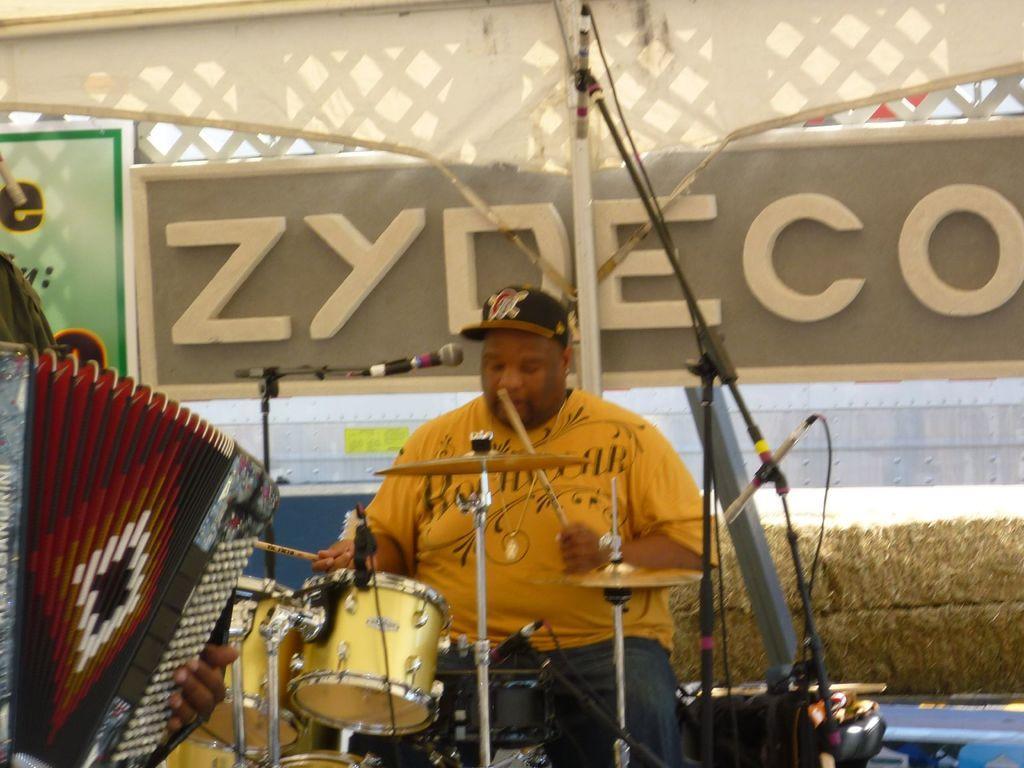Please provide a concise description of this image. There is a man sitting and playing musical instrument. We can see microphones with stands. In the background we can see boards and wall. On the left side of the image we can see a person holding a musical instrument. 